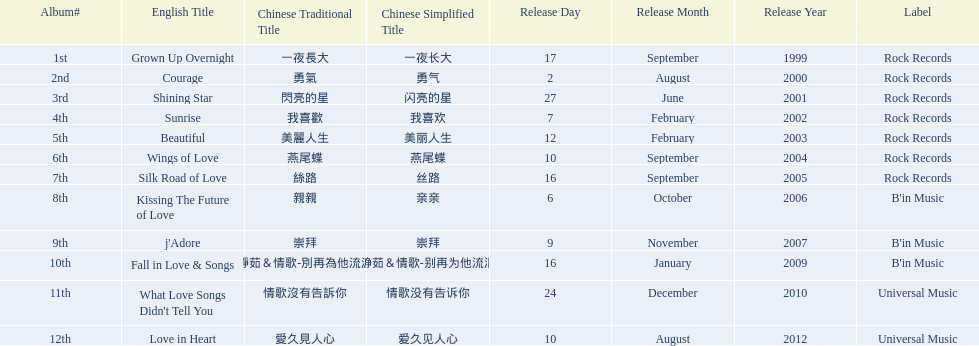What songs were on b'in music or universal music? Kissing The Future of Love, j'Adore, Fall in Love & Songs, What Love Songs Didn't Tell You, Love in Heart. 